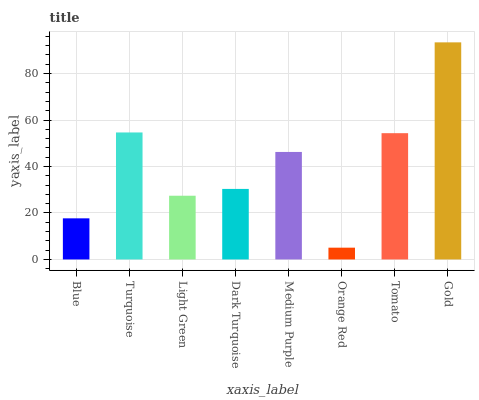Is Turquoise the minimum?
Answer yes or no. No. Is Turquoise the maximum?
Answer yes or no. No. Is Turquoise greater than Blue?
Answer yes or no. Yes. Is Blue less than Turquoise?
Answer yes or no. Yes. Is Blue greater than Turquoise?
Answer yes or no. No. Is Turquoise less than Blue?
Answer yes or no. No. Is Medium Purple the high median?
Answer yes or no. Yes. Is Dark Turquoise the low median?
Answer yes or no. Yes. Is Turquoise the high median?
Answer yes or no. No. Is Turquoise the low median?
Answer yes or no. No. 